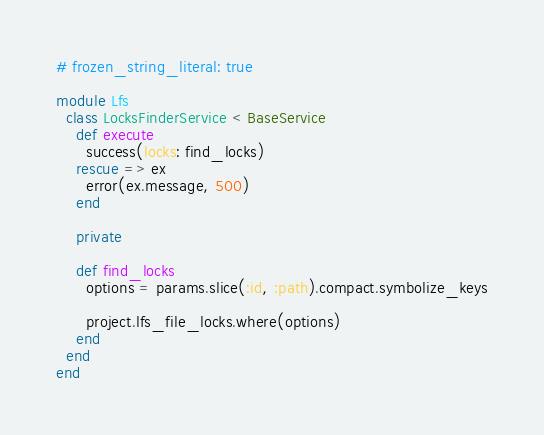<code> <loc_0><loc_0><loc_500><loc_500><_Ruby_># frozen_string_literal: true

module Lfs
  class LocksFinderService < BaseService
    def execute
      success(locks: find_locks)
    rescue => ex
      error(ex.message, 500)
    end

    private

    def find_locks
      options = params.slice(:id, :path).compact.symbolize_keys

      project.lfs_file_locks.where(options)
    end
  end
end
</code> 